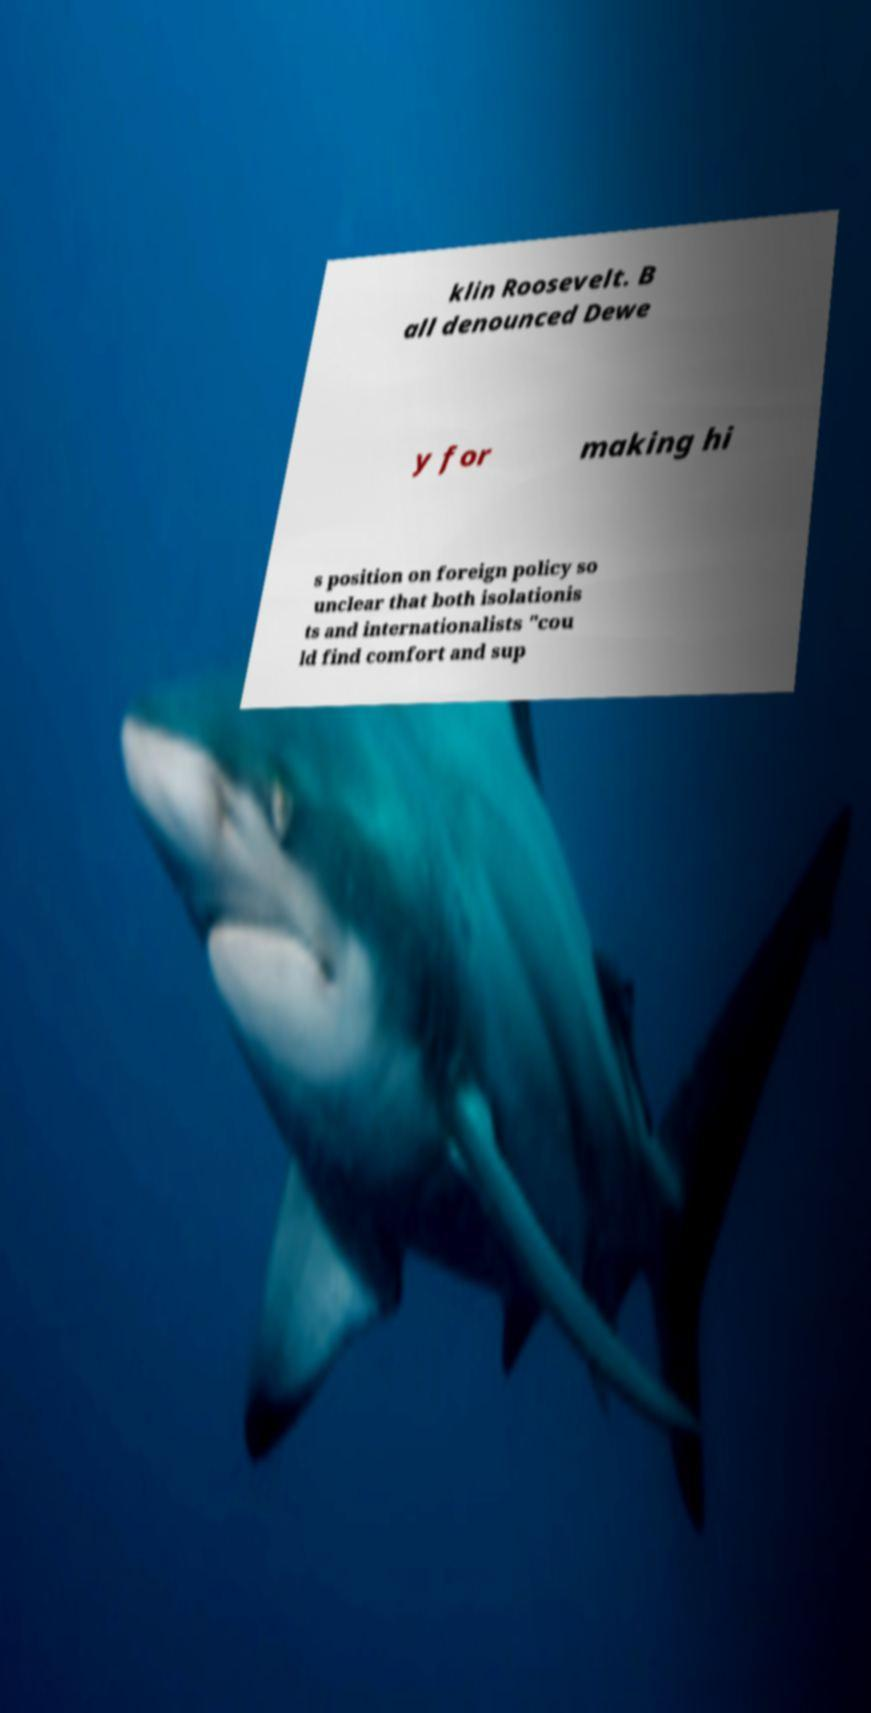There's text embedded in this image that I need extracted. Can you transcribe it verbatim? klin Roosevelt. B all denounced Dewe y for making hi s position on foreign policy so unclear that both isolationis ts and internationalists "cou ld find comfort and sup 